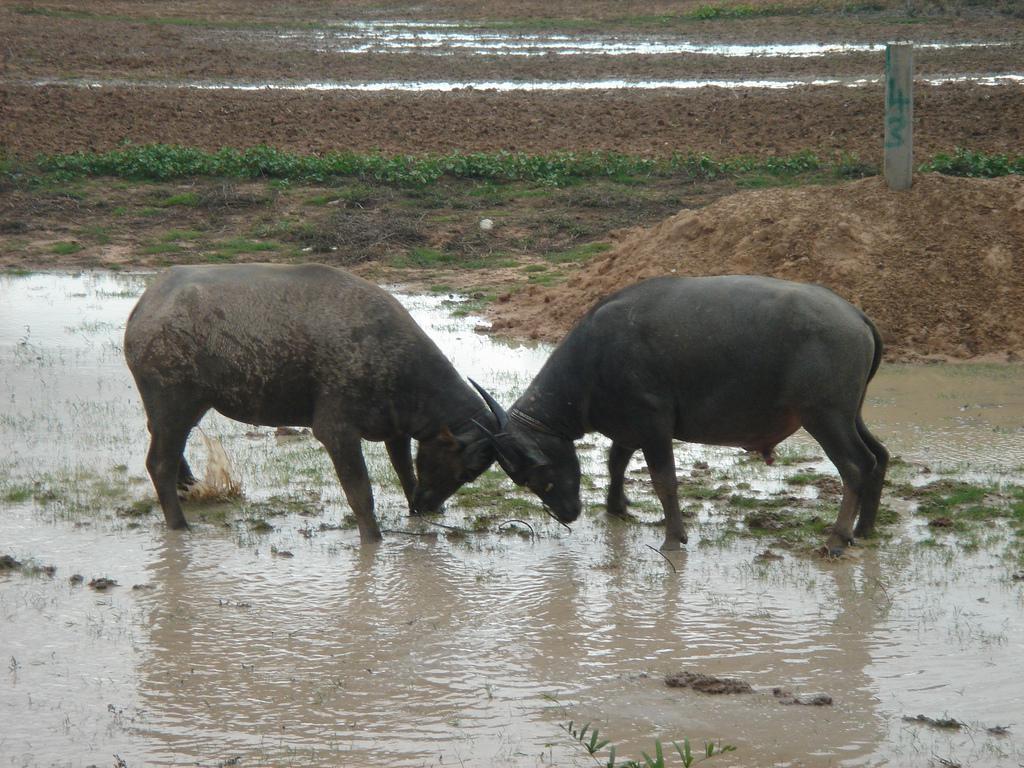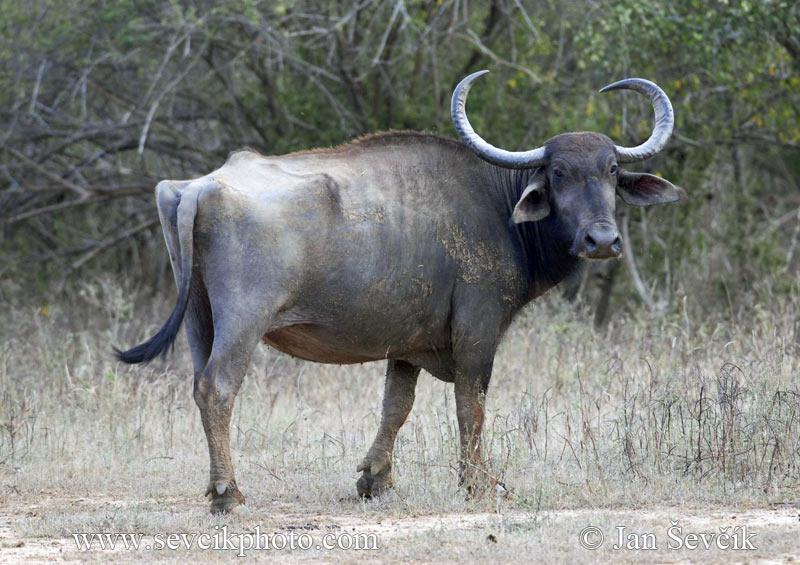The first image is the image on the left, the second image is the image on the right. Given the left and right images, does the statement "there are 2 bulls" hold true? Answer yes or no. No. 